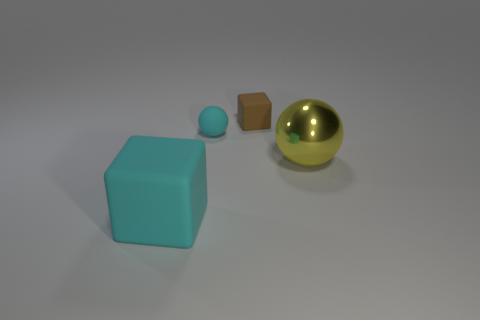Add 1 big gray shiny blocks. How many objects exist? 5 Subtract 1 blocks. How many blocks are left? 1 Subtract all gray spheres. Subtract all yellow cylinders. How many spheres are left? 2 Subtract all brown spheres. How many brown blocks are left? 1 Subtract all purple shiny blocks. Subtract all large rubber things. How many objects are left? 3 Add 2 big things. How many big things are left? 4 Add 2 big metallic spheres. How many big metallic spheres exist? 3 Subtract all yellow balls. How many balls are left? 1 Subtract 0 green cubes. How many objects are left? 4 